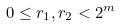Convert formula to latex. <formula><loc_0><loc_0><loc_500><loc_500>0 \leq r _ { 1 } , r _ { 2 } < 2 ^ { m }</formula> 